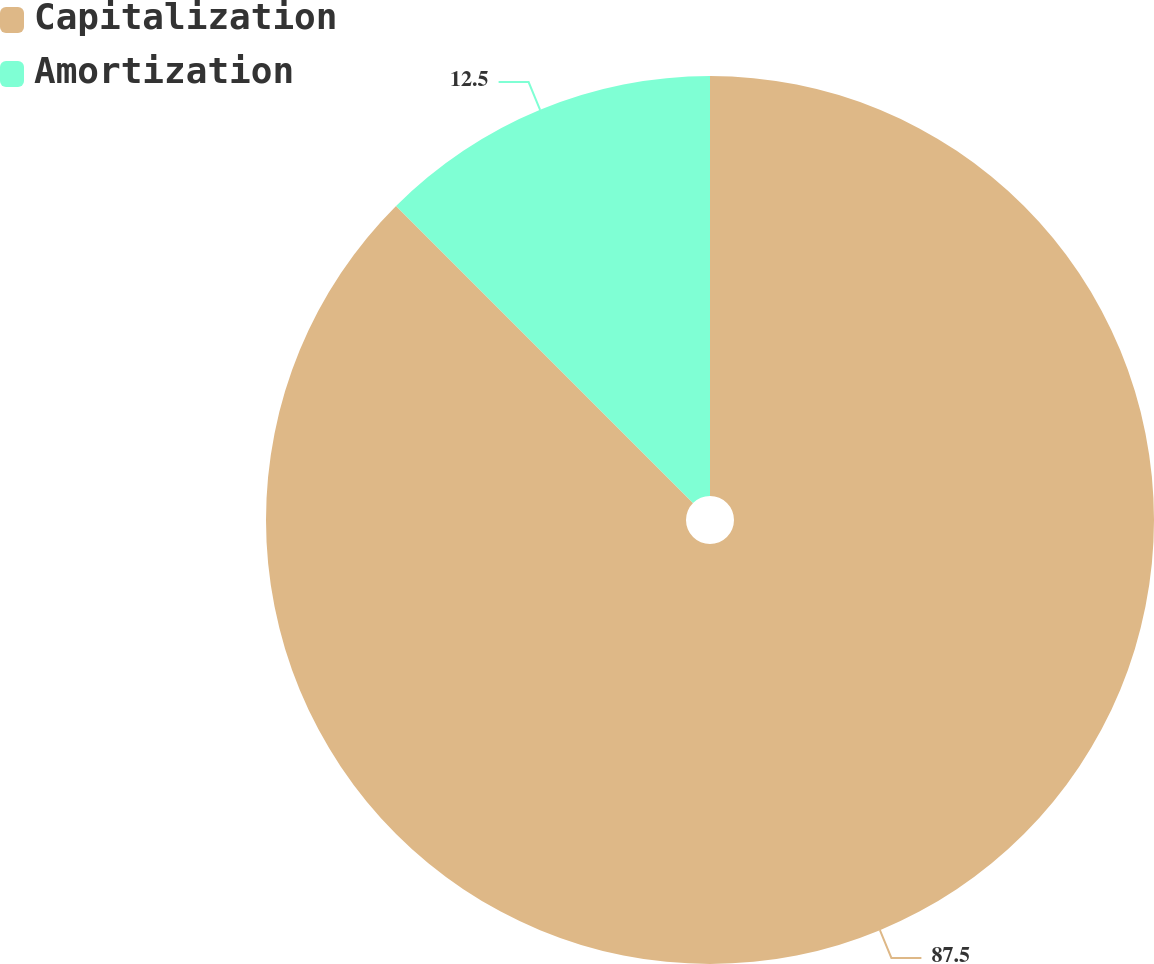Convert chart to OTSL. <chart><loc_0><loc_0><loc_500><loc_500><pie_chart><fcel>Capitalization<fcel>Amortization<nl><fcel>87.5%<fcel>12.5%<nl></chart> 